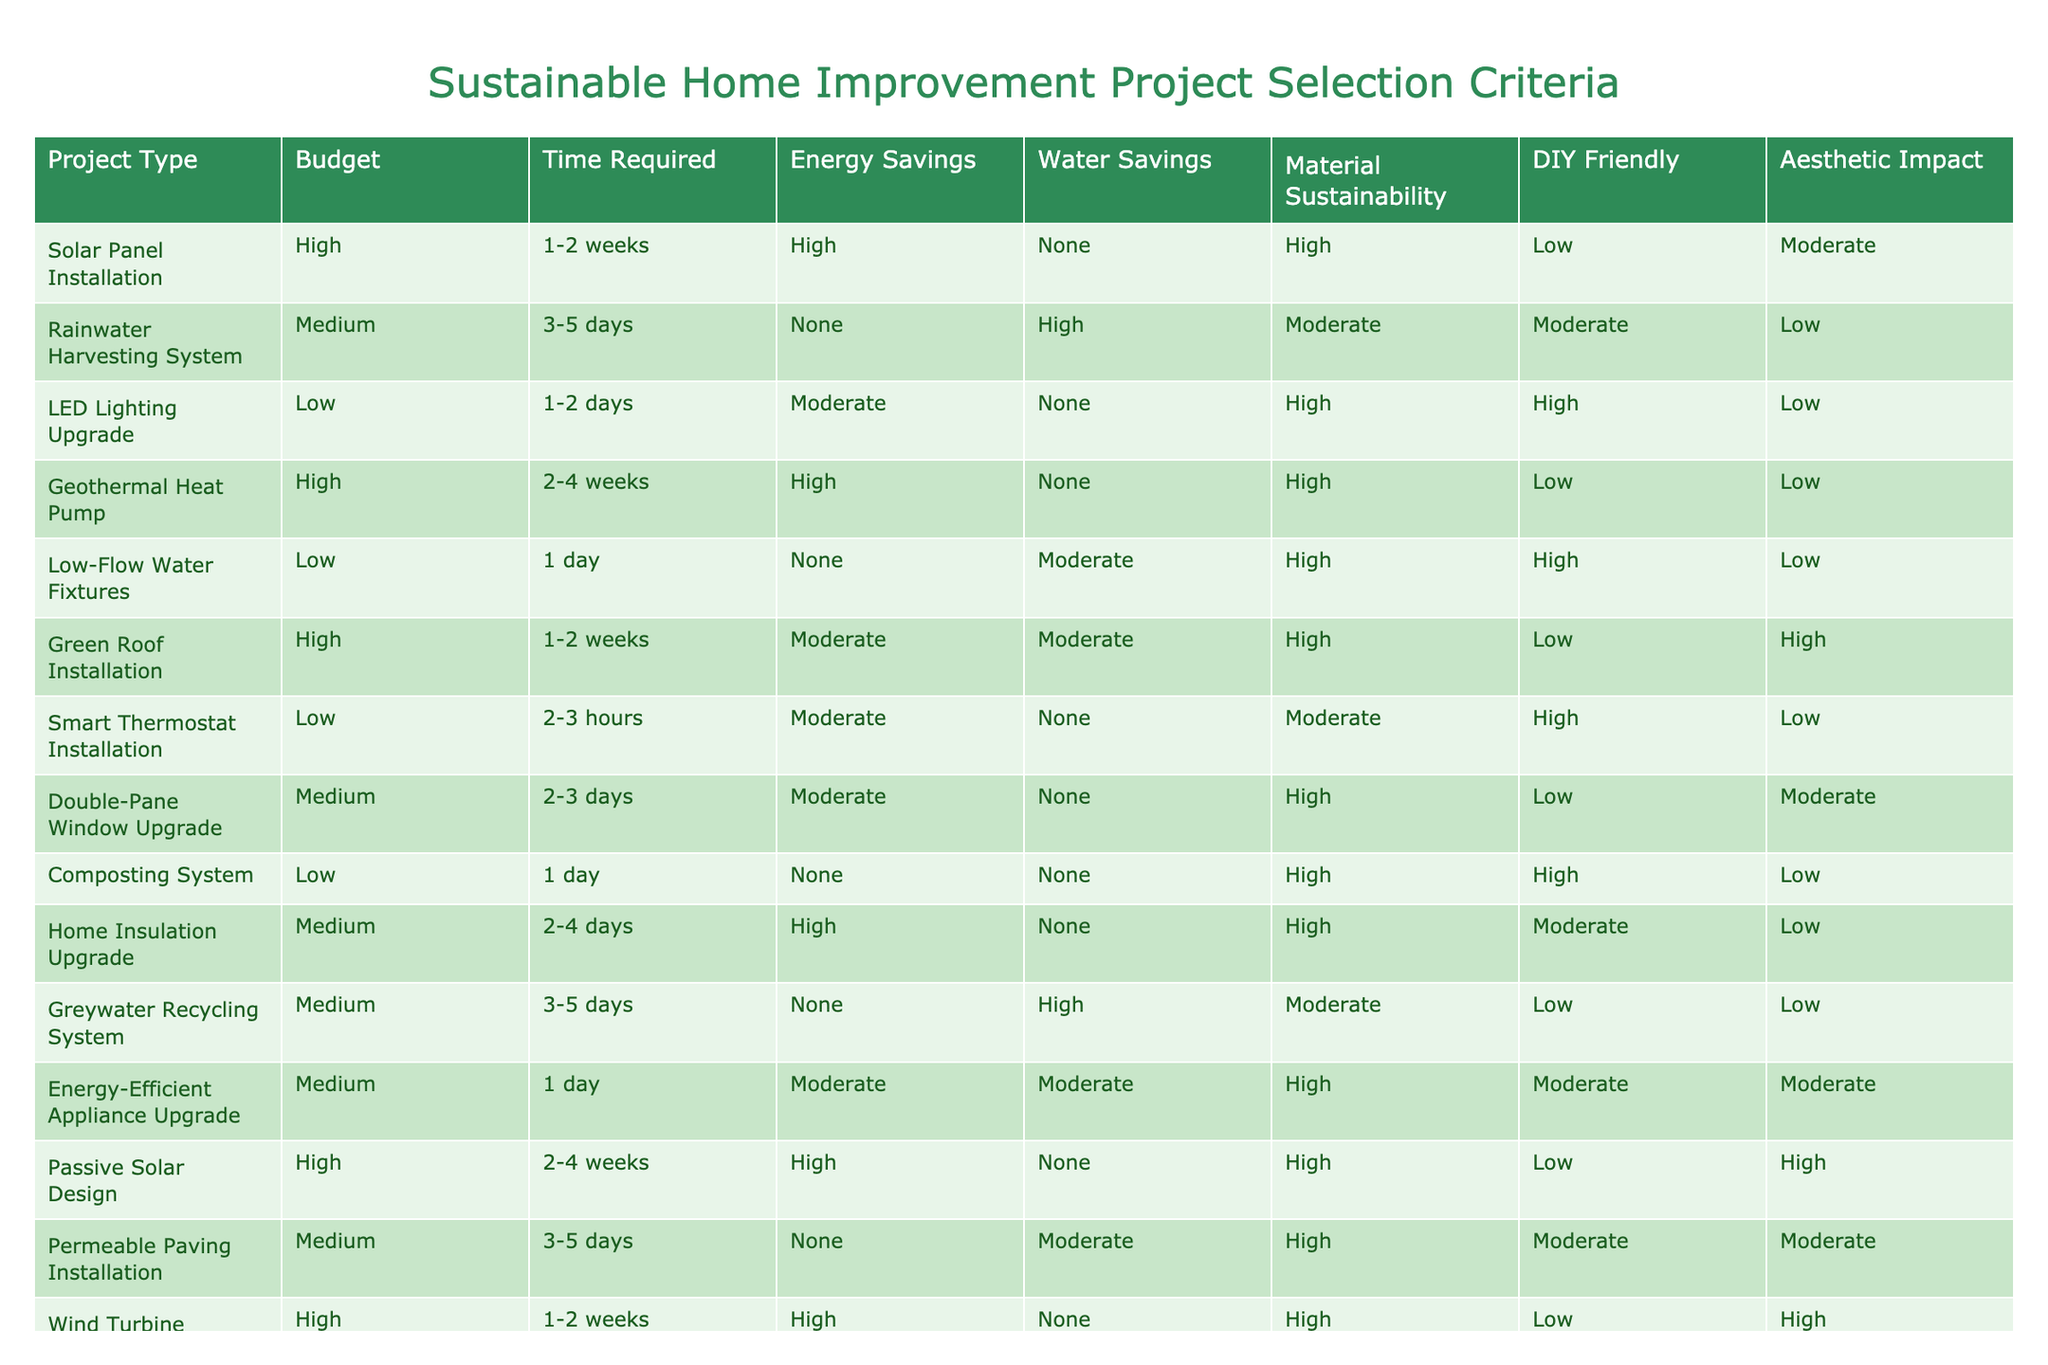What is the budget range for the 'LED Lighting Upgrade' project? The LED Lighting Upgrade project is listed under the 'Budget' column with a value of 'Low.'
Answer: Low How many projects have a 'High' material sustainability rating? By reviewing the 'Material Sustainability' column, I can see that the following projects have a 'High' rating: Solar Panel Installation, Geothermal Heat Pump, Low-Flow Water Fixtures, Green Roof Installation, Passive Solar Design, Wind Turbine Installation. That's a total of 6 projects.
Answer: 6 Are there any projects that offer both energy and water savings? I look at the 'Energy Savings' and 'Water Savings' columns. The projects that have 'High' in energy savings include Solar Panel Installation, Geothermal Heat Pump, Home Insulation Upgrade, and Passive Solar Design. The only project that offers 'High' water savings alongside them is Home Insulation Upgrade. So the answer is no.
Answer: No Which project type requires the most time to complete? I will compare the 'Time Required' values for all projects, identifying that 'Geothermal Heat Pump' and 'Passive Solar Design' take 2-4 weeks, which is the longest duration listed in the table. Both take the same amount of time.
Answer: Geothermal Heat Pump and Passive Solar Design What is the average time required for projects that are 'DIY Friendly'? I look for projects listed as 'DIY Friendly,' which are LED Lighting Upgrade, Low-Flow Water Fixtures, Composting System, and Smart Thermostat Installation. Their time requirements in days are 1.5, 1, 1, and 0.5 respectively, totaling 4 days. Dividing this by 4 projects gives an average of 1 day.
Answer: 1 day Is there any project that delivers energy savings but requires a low budget? Looking at the table, I find the 'Smart Thermostat Installation' and 'LED Lighting Upgrade' both listed in the low budget category, while also having moderate energy savings compared to the higher-rated projects. Therefore, yes, these options do exist.
Answer: Yes How many projects have a 'Moderate' aesthetic impact? By reviewing the 'Aesthetic Impact' column, the projects with a 'Moderate' rating include Energy-Efficient Appliance Upgrade, Double-Pane Window Upgrade, and Permeable Paving Installation. Counting these, I find there are 3 projects.
Answer: 3 